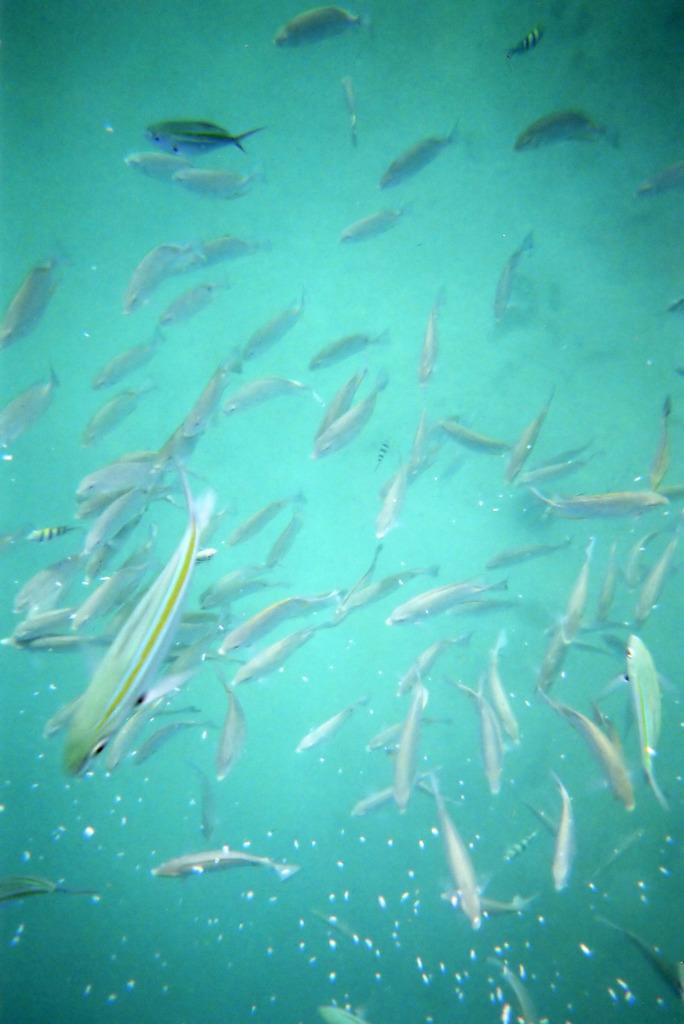Could you give a brief overview of what you see in this image? In this image, we can see fishes in the water all over the image. 